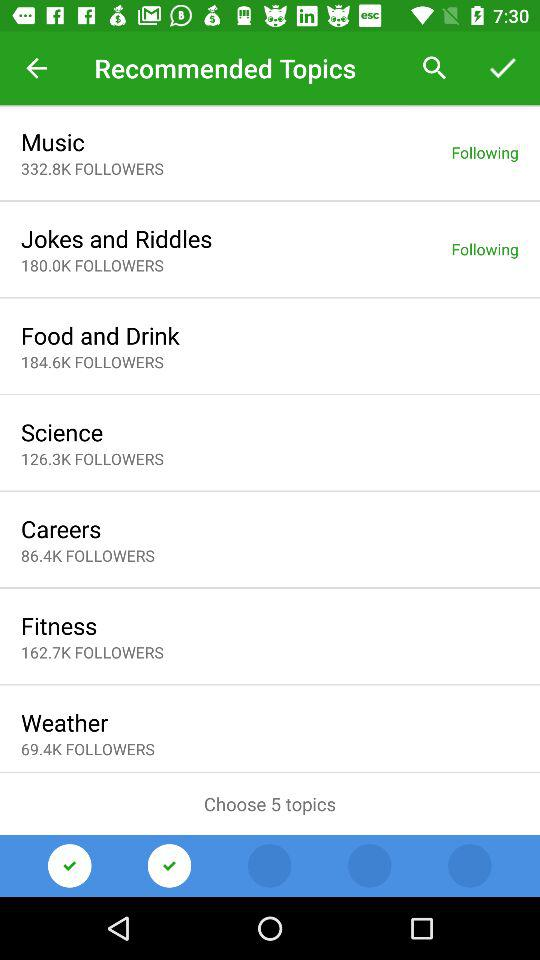What are the two topic names that are following by the user? The two topic names are "Music" and "Jokes and Riddles". 